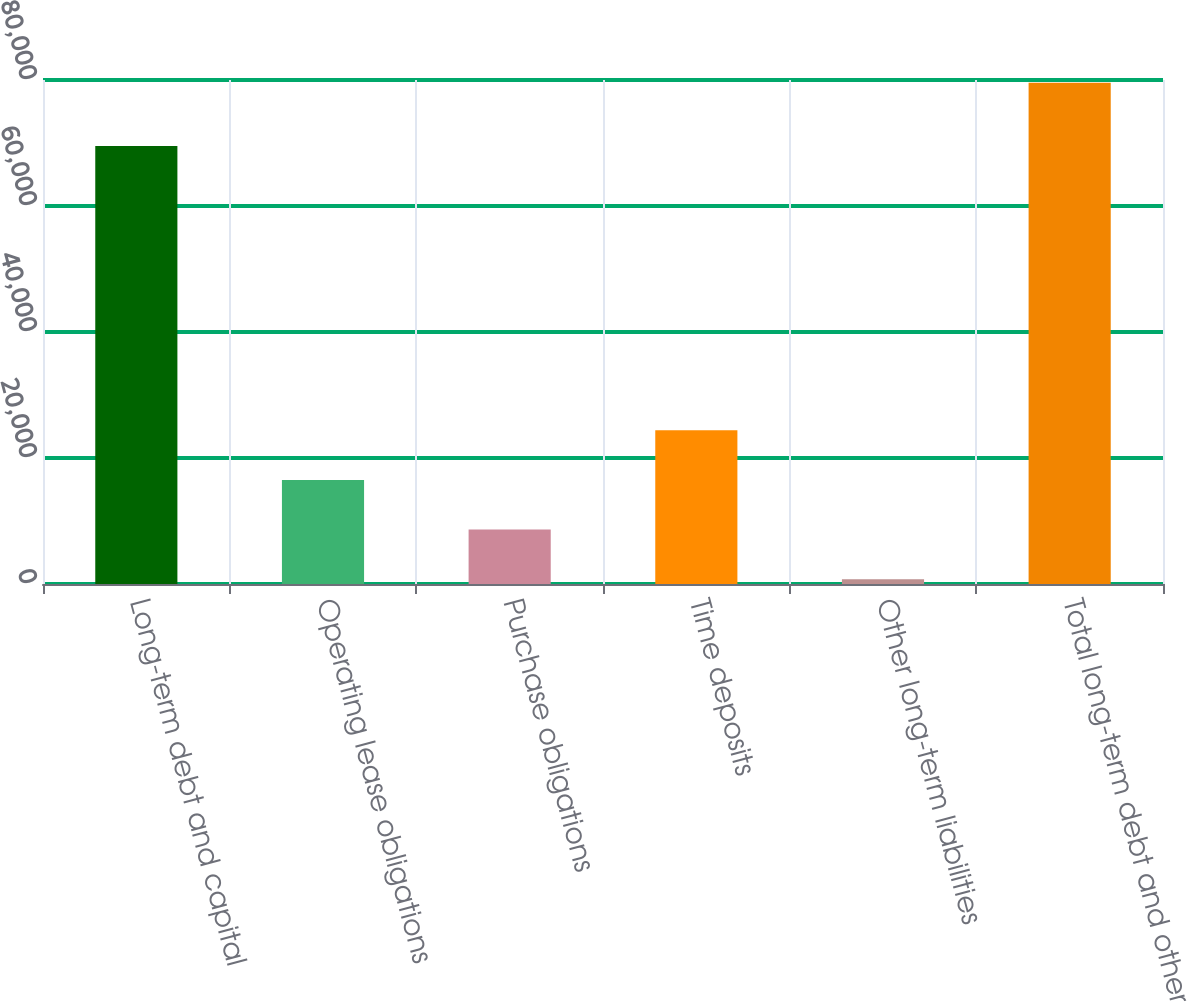Convert chart. <chart><loc_0><loc_0><loc_500><loc_500><bar_chart><fcel>Long-term debt and capital<fcel>Operating lease obligations<fcel>Purchase obligations<fcel>Time deposits<fcel>Other long-term liabilities<fcel>Total long-term debt and other<nl><fcel>69539<fcel>16527.6<fcel>8648.8<fcel>24406.4<fcel>770<fcel>79558<nl></chart> 